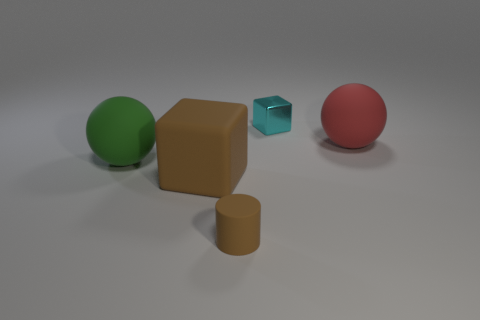Subtract all blue cylinders. Subtract all red cubes. How many cylinders are left? 1 Add 5 big red spheres. How many objects exist? 10 Subtract all cubes. How many objects are left? 3 Subtract 1 cyan cubes. How many objects are left? 4 Subtract all tiny red cylinders. Subtract all large rubber spheres. How many objects are left? 3 Add 5 matte objects. How many matte objects are left? 9 Add 1 tiny brown matte cylinders. How many tiny brown matte cylinders exist? 2 